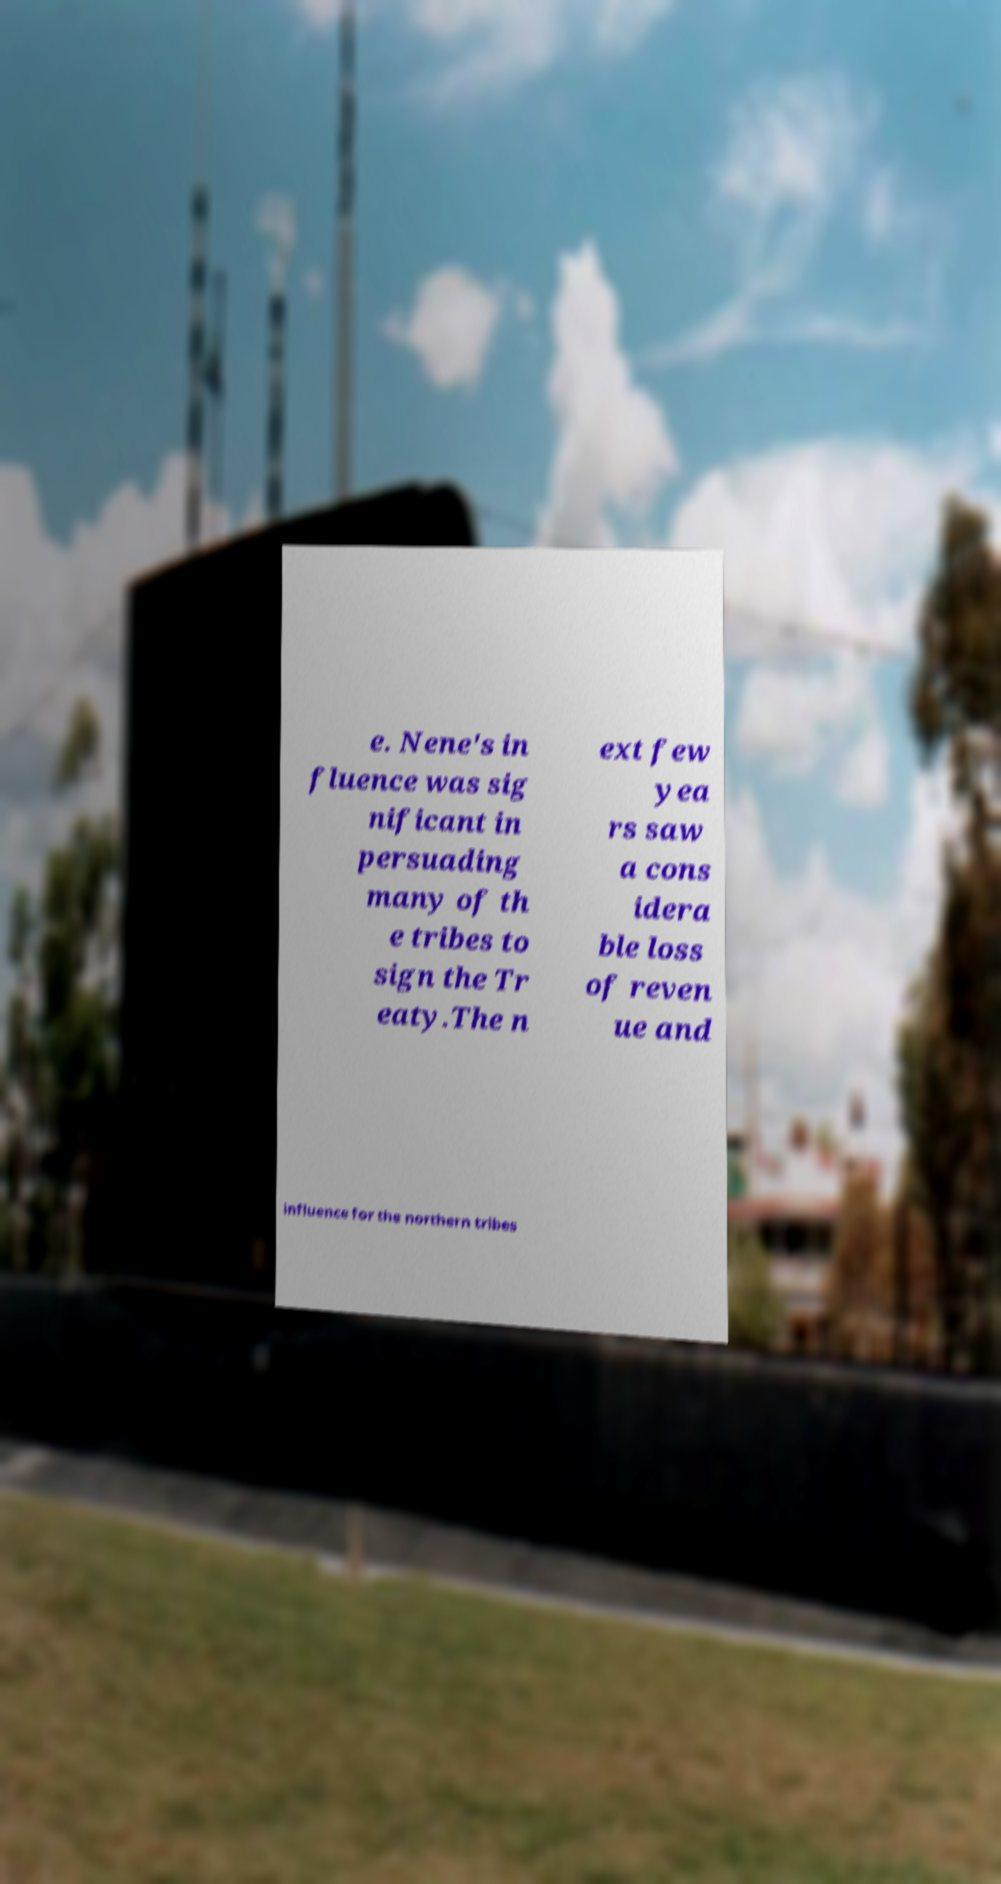For documentation purposes, I need the text within this image transcribed. Could you provide that? e. Nene's in fluence was sig nificant in persuading many of th e tribes to sign the Tr eaty.The n ext few yea rs saw a cons idera ble loss of reven ue and influence for the northern tribes 